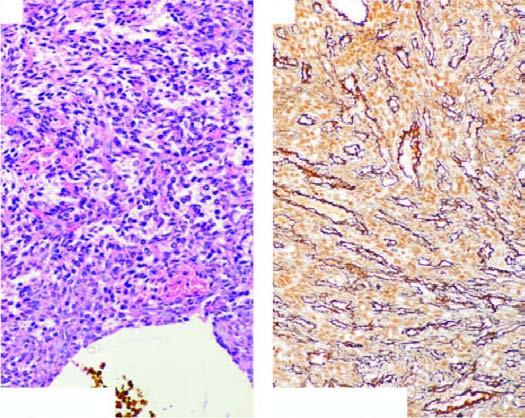what surround the vascular lumina in a whorled fashion, highlighted by reticulin stain?
Answer the question using a single word or phrase. Spindled cells 